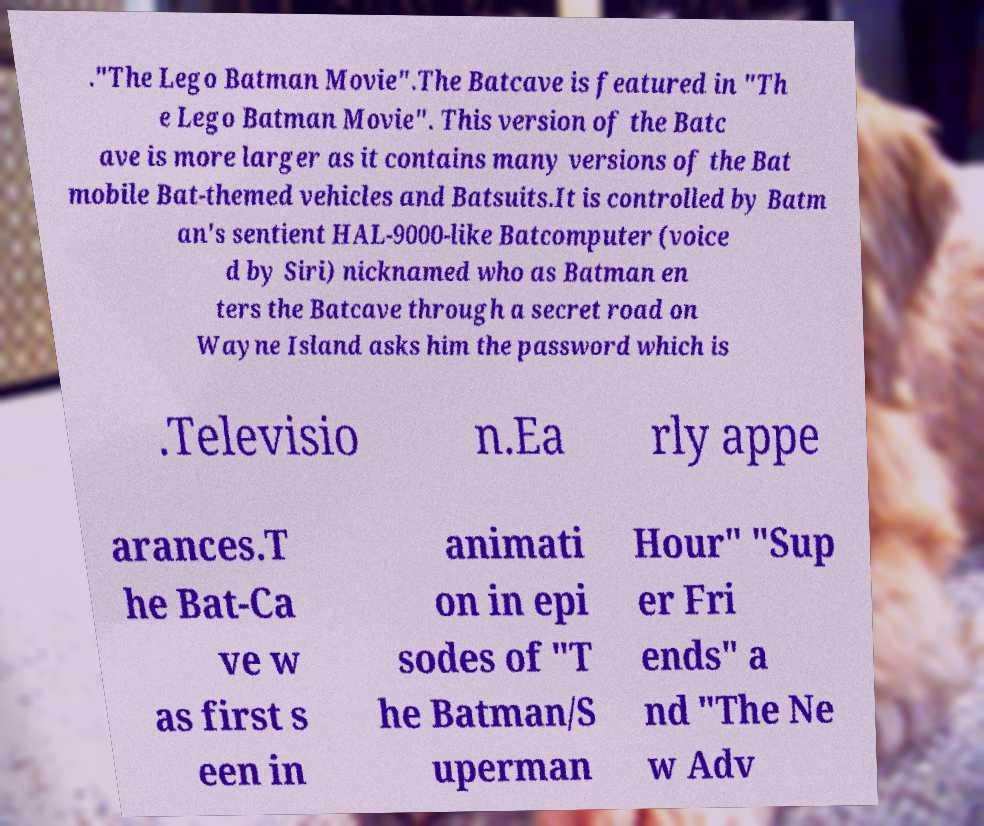For documentation purposes, I need the text within this image transcribed. Could you provide that? ."The Lego Batman Movie".The Batcave is featured in "Th e Lego Batman Movie". This version of the Batc ave is more larger as it contains many versions of the Bat mobile Bat-themed vehicles and Batsuits.It is controlled by Batm an's sentient HAL-9000-like Batcomputer (voice d by Siri) nicknamed who as Batman en ters the Batcave through a secret road on Wayne Island asks him the password which is .Televisio n.Ea rly appe arances.T he Bat-Ca ve w as first s een in animati on in epi sodes of "T he Batman/S uperman Hour" "Sup er Fri ends" a nd "The Ne w Adv 